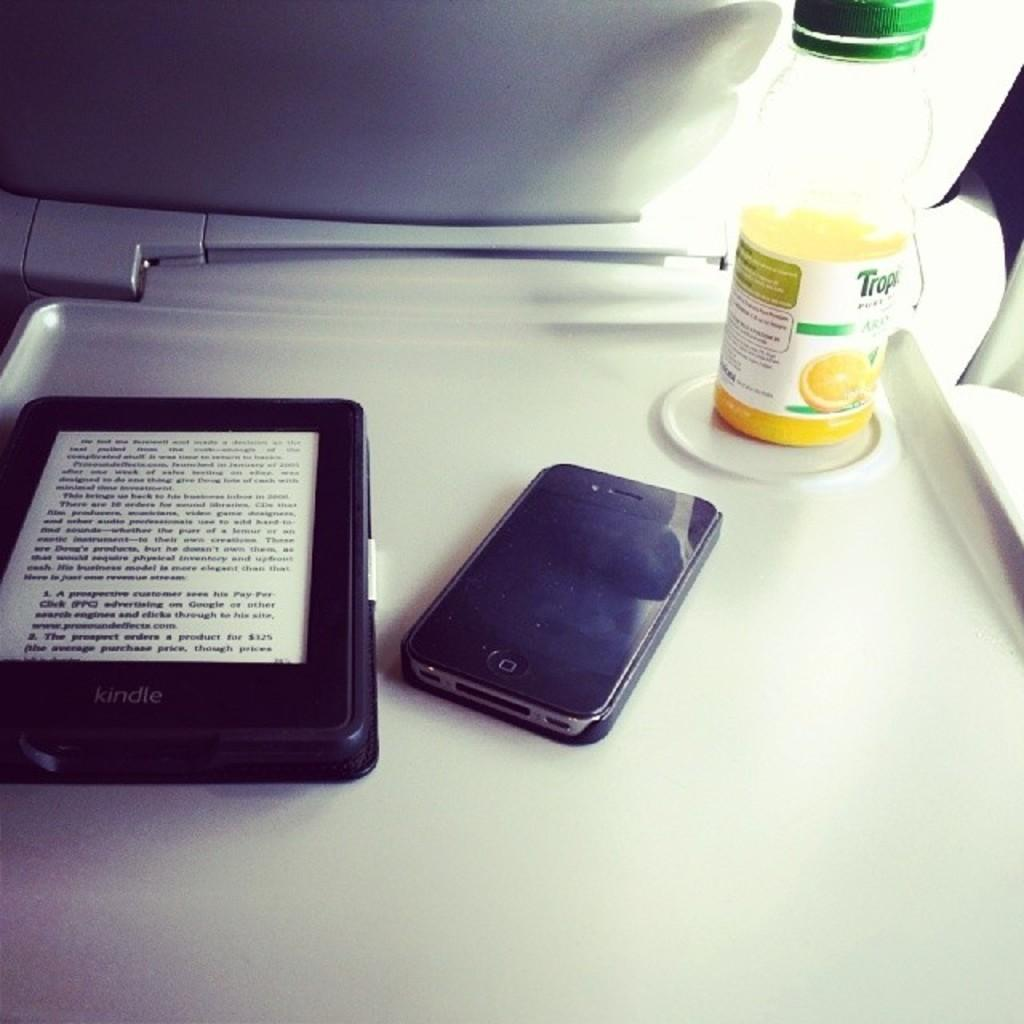Provide a one-sentence caption for the provided image. Tray table that shows a kindle with a book to the left and to the right is a older I phone sitting next to a single serving of Orange juice. 